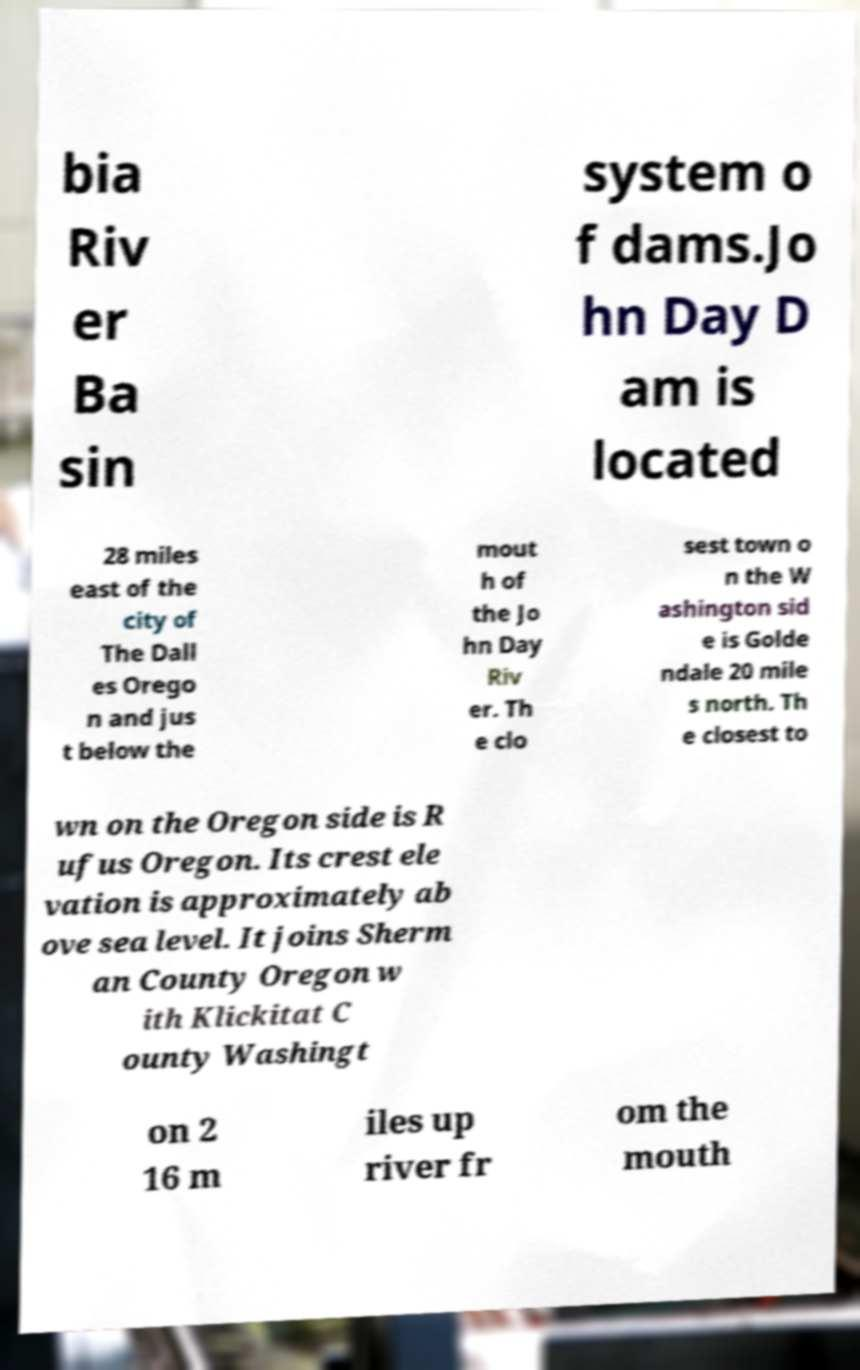Can you read and provide the text displayed in the image?This photo seems to have some interesting text. Can you extract and type it out for me? bia Riv er Ba sin system o f dams.Jo hn Day D am is located 28 miles east of the city of The Dall es Orego n and jus t below the mout h of the Jo hn Day Riv er. Th e clo sest town o n the W ashington sid e is Golde ndale 20 mile s north. Th e closest to wn on the Oregon side is R ufus Oregon. Its crest ele vation is approximately ab ove sea level. It joins Sherm an County Oregon w ith Klickitat C ounty Washingt on 2 16 m iles up river fr om the mouth 